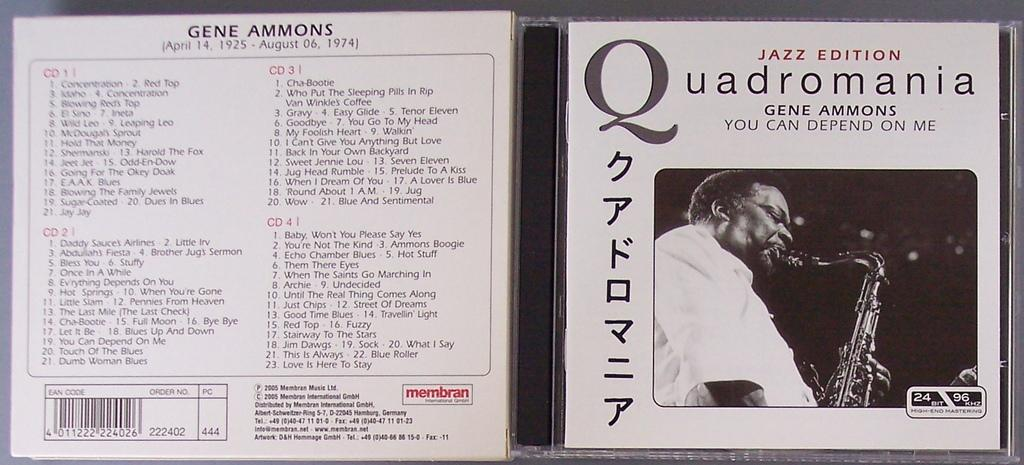<image>
Share a concise interpretation of the image provided. a cd cover that says 'jazz edition, quadromania' on it 